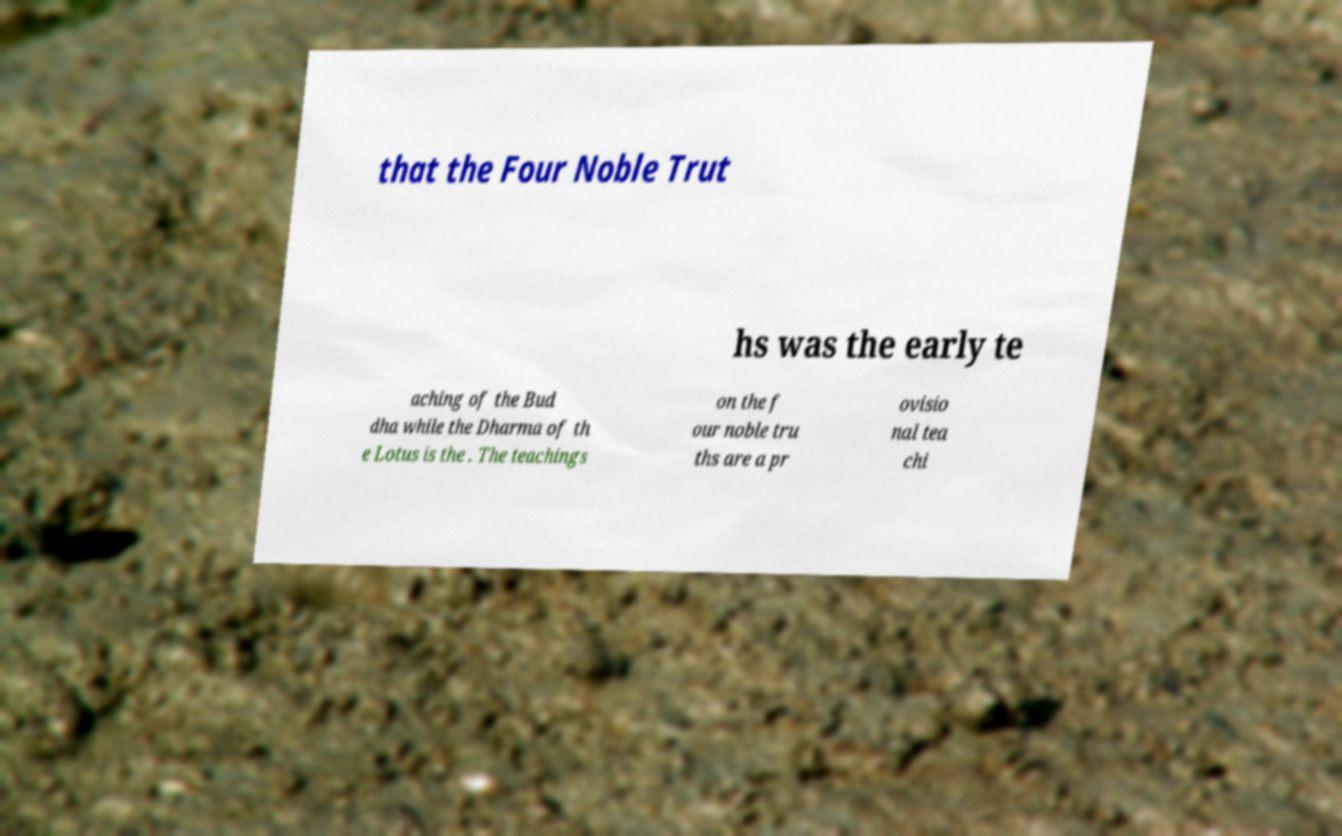Please read and relay the text visible in this image. What does it say? that the Four Noble Trut hs was the early te aching of the Bud dha while the Dharma of th e Lotus is the . The teachings on the f our noble tru ths are a pr ovisio nal tea chi 